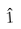Convert formula to latex. <formula><loc_0><loc_0><loc_500><loc_500>\hat { 1 }</formula> 